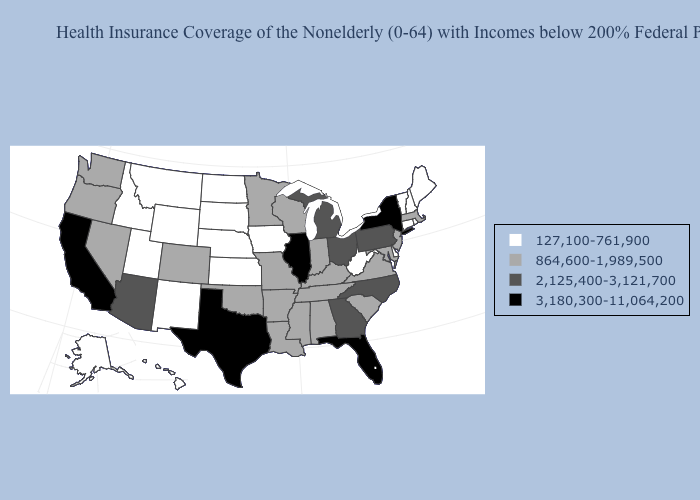Name the states that have a value in the range 864,600-1,989,500?
Give a very brief answer. Alabama, Arkansas, Colorado, Indiana, Kentucky, Louisiana, Maryland, Massachusetts, Minnesota, Mississippi, Missouri, Nevada, New Jersey, Oklahoma, Oregon, South Carolina, Tennessee, Virginia, Washington, Wisconsin. Which states have the lowest value in the West?
Give a very brief answer. Alaska, Hawaii, Idaho, Montana, New Mexico, Utah, Wyoming. Does New Jersey have the highest value in the Northeast?
Write a very short answer. No. Which states have the lowest value in the USA?
Write a very short answer. Alaska, Connecticut, Delaware, Hawaii, Idaho, Iowa, Kansas, Maine, Montana, Nebraska, New Hampshire, New Mexico, North Dakota, Rhode Island, South Dakota, Utah, Vermont, West Virginia, Wyoming. Does Connecticut have the lowest value in the USA?
Quick response, please. Yes. What is the lowest value in states that border Minnesota?
Quick response, please. 127,100-761,900. Does the first symbol in the legend represent the smallest category?
Give a very brief answer. Yes. What is the value of Oklahoma?
Be succinct. 864,600-1,989,500. Is the legend a continuous bar?
Write a very short answer. No. Name the states that have a value in the range 864,600-1,989,500?
Answer briefly. Alabama, Arkansas, Colorado, Indiana, Kentucky, Louisiana, Maryland, Massachusetts, Minnesota, Mississippi, Missouri, Nevada, New Jersey, Oklahoma, Oregon, South Carolina, Tennessee, Virginia, Washington, Wisconsin. Name the states that have a value in the range 864,600-1,989,500?
Write a very short answer. Alabama, Arkansas, Colorado, Indiana, Kentucky, Louisiana, Maryland, Massachusetts, Minnesota, Mississippi, Missouri, Nevada, New Jersey, Oklahoma, Oregon, South Carolina, Tennessee, Virginia, Washington, Wisconsin. Does Pennsylvania have the lowest value in the Northeast?
Keep it brief. No. Among the states that border Florida , which have the lowest value?
Give a very brief answer. Alabama. What is the value of Alaska?
Write a very short answer. 127,100-761,900. Does Michigan have a higher value than Illinois?
Be succinct. No. 